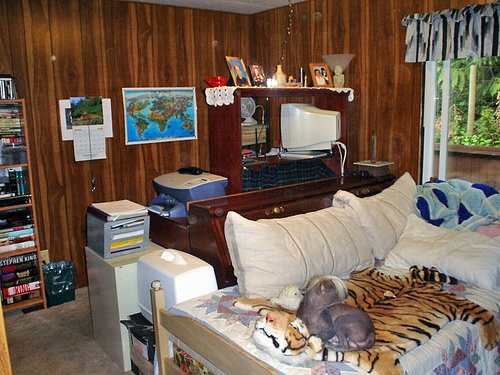Describe the objects in this image and their specific colors. I can see bed in black, darkgray, lightgray, gray, and tan tones, book in black, maroon, and gray tones, dog in black, gray, darkgray, and maroon tones, tv in black, darkgray, lightgray, and tan tones, and book in black, brown, maroon, and darkgray tones in this image. 